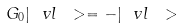<formula> <loc_0><loc_0><loc_500><loc_500>G _ { 0 } | \ v l \ > = - | \ v l \ ></formula> 